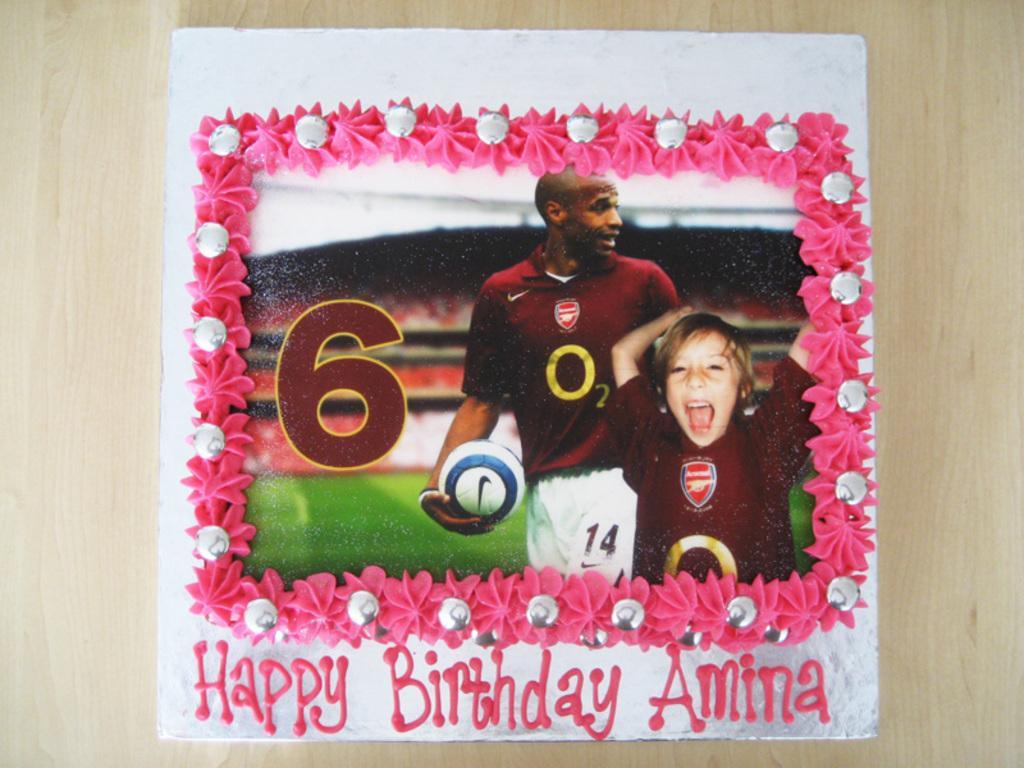In one or two sentences, can you explain what this image depicts? In this image I can see the cream colored surface and on it I can see a cake which is white and pink in color. On the cake I can see a photograph in which I can see two persons wearing brown and white colored dress are standing, the ground, the stadium and I can see a person is holding a ball. 